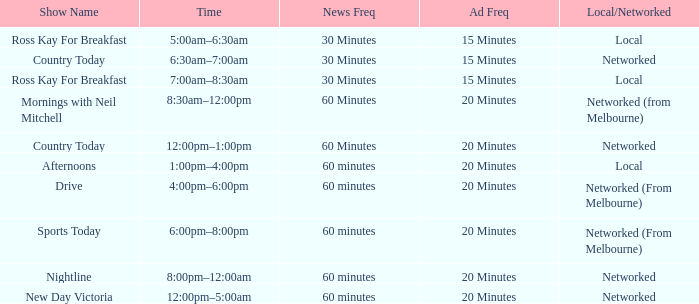What News Freq has a Time of 1:00pm–4:00pm? 60 minutes. 